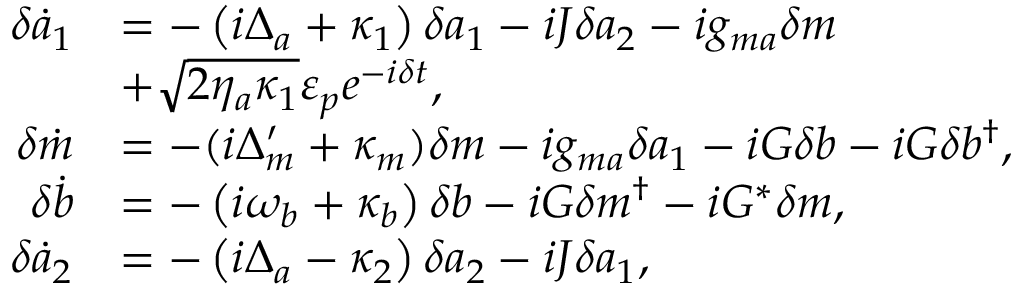Convert formula to latex. <formula><loc_0><loc_0><loc_500><loc_500>\begin{array} { r l } { \delta \dot { a } _ { 1 } } & { = - \left ( i \Delta _ { a } + \kappa _ { 1 } \right ) \delta a _ { 1 } - i J \delta a _ { 2 } - i g _ { m a } \delta m } \\ & { + \sqrt { 2 \eta _ { a } \kappa _ { 1 } } \varepsilon _ { p } e ^ { - i \delta t } , } \\ { \delta \dot { m } } & { = - ( i \Delta _ { m } ^ { \prime } + \kappa _ { m } ) \delta m - i g _ { m a } \delta a _ { 1 } - i G \delta b - i G \delta b ^ { \dagger } , } \\ { \delta \dot { b } } & { = - \left ( i \omega _ { b } + \kappa _ { b } \right ) \delta b - i G \delta m ^ { \dagger } - i G ^ { * } \delta m , } \\ { \delta \dot { a } _ { 2 } } & { = - \left ( i \Delta _ { a } - \kappa _ { 2 } \right ) \delta a _ { 2 } - i J \delta a _ { 1 } , } \end{array}</formula> 